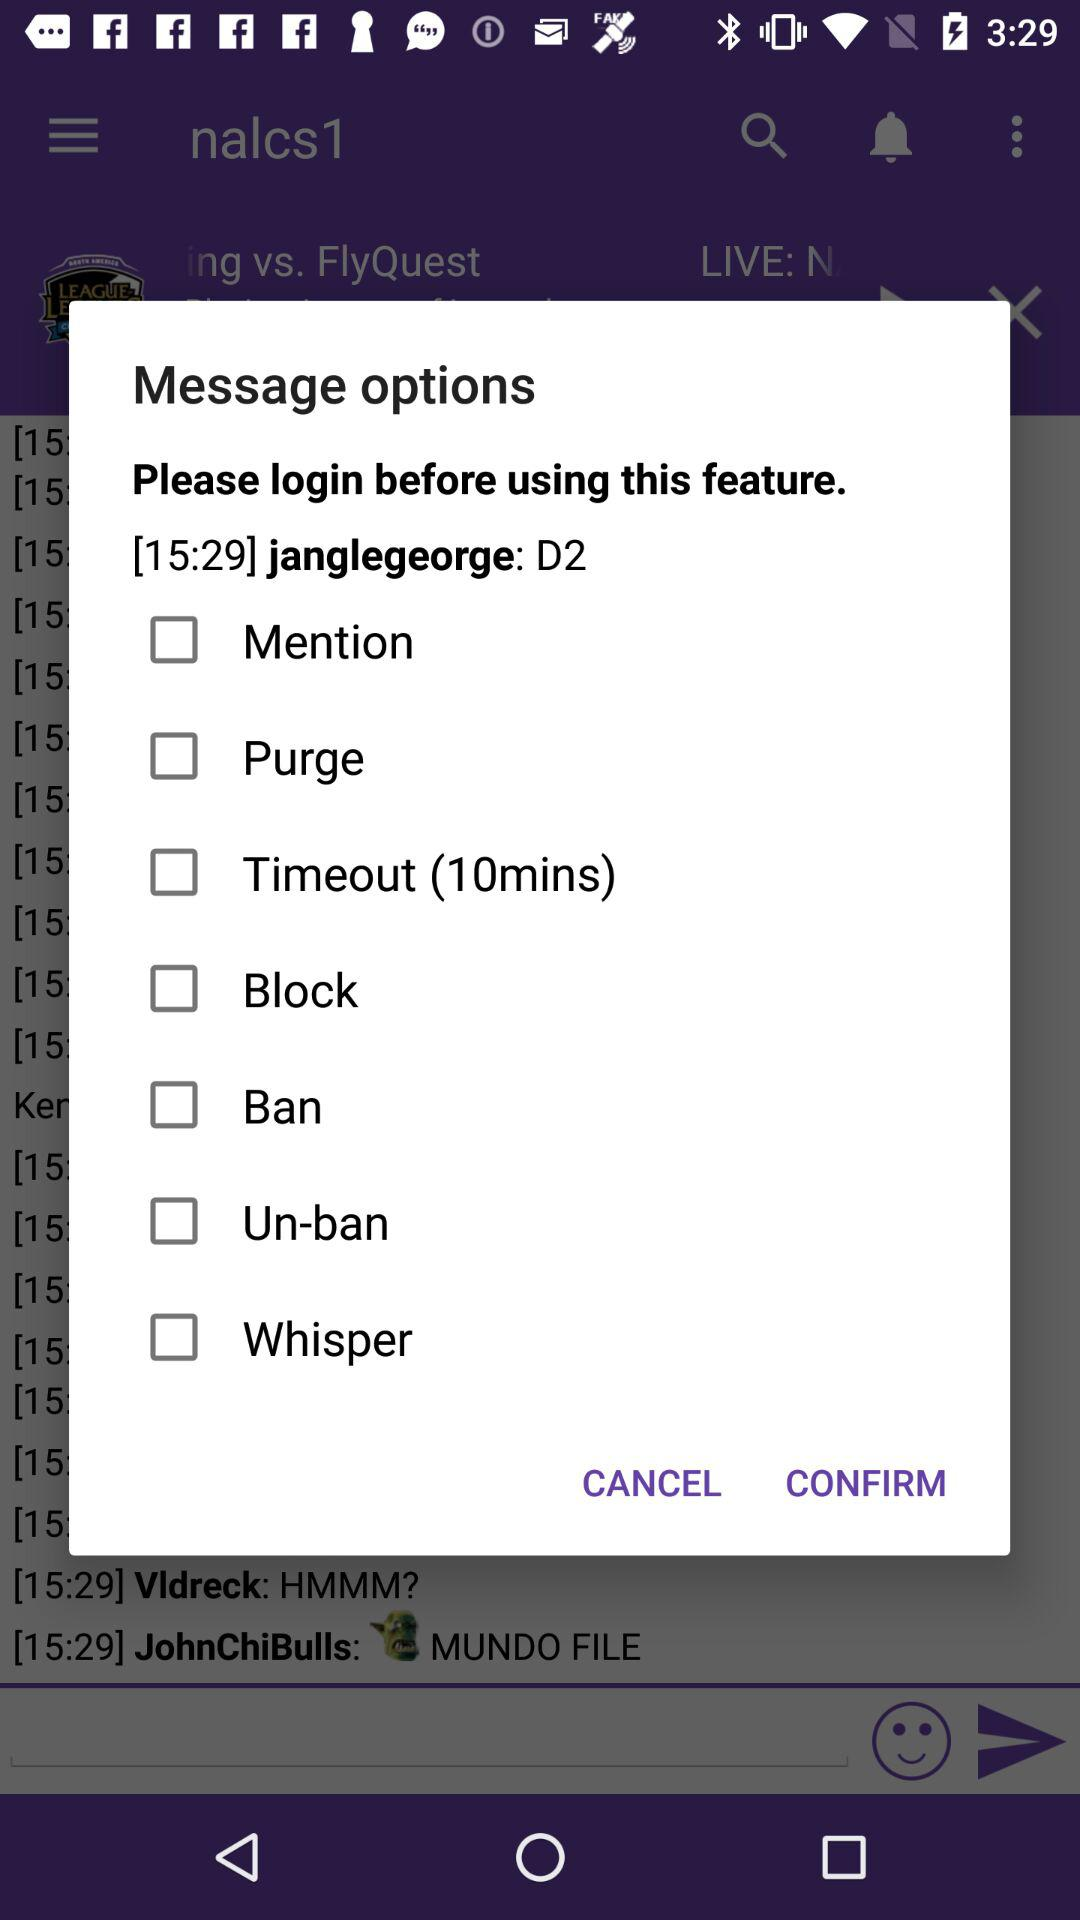What is the time duration given for the timeout? The given duration is 10 minutes. 